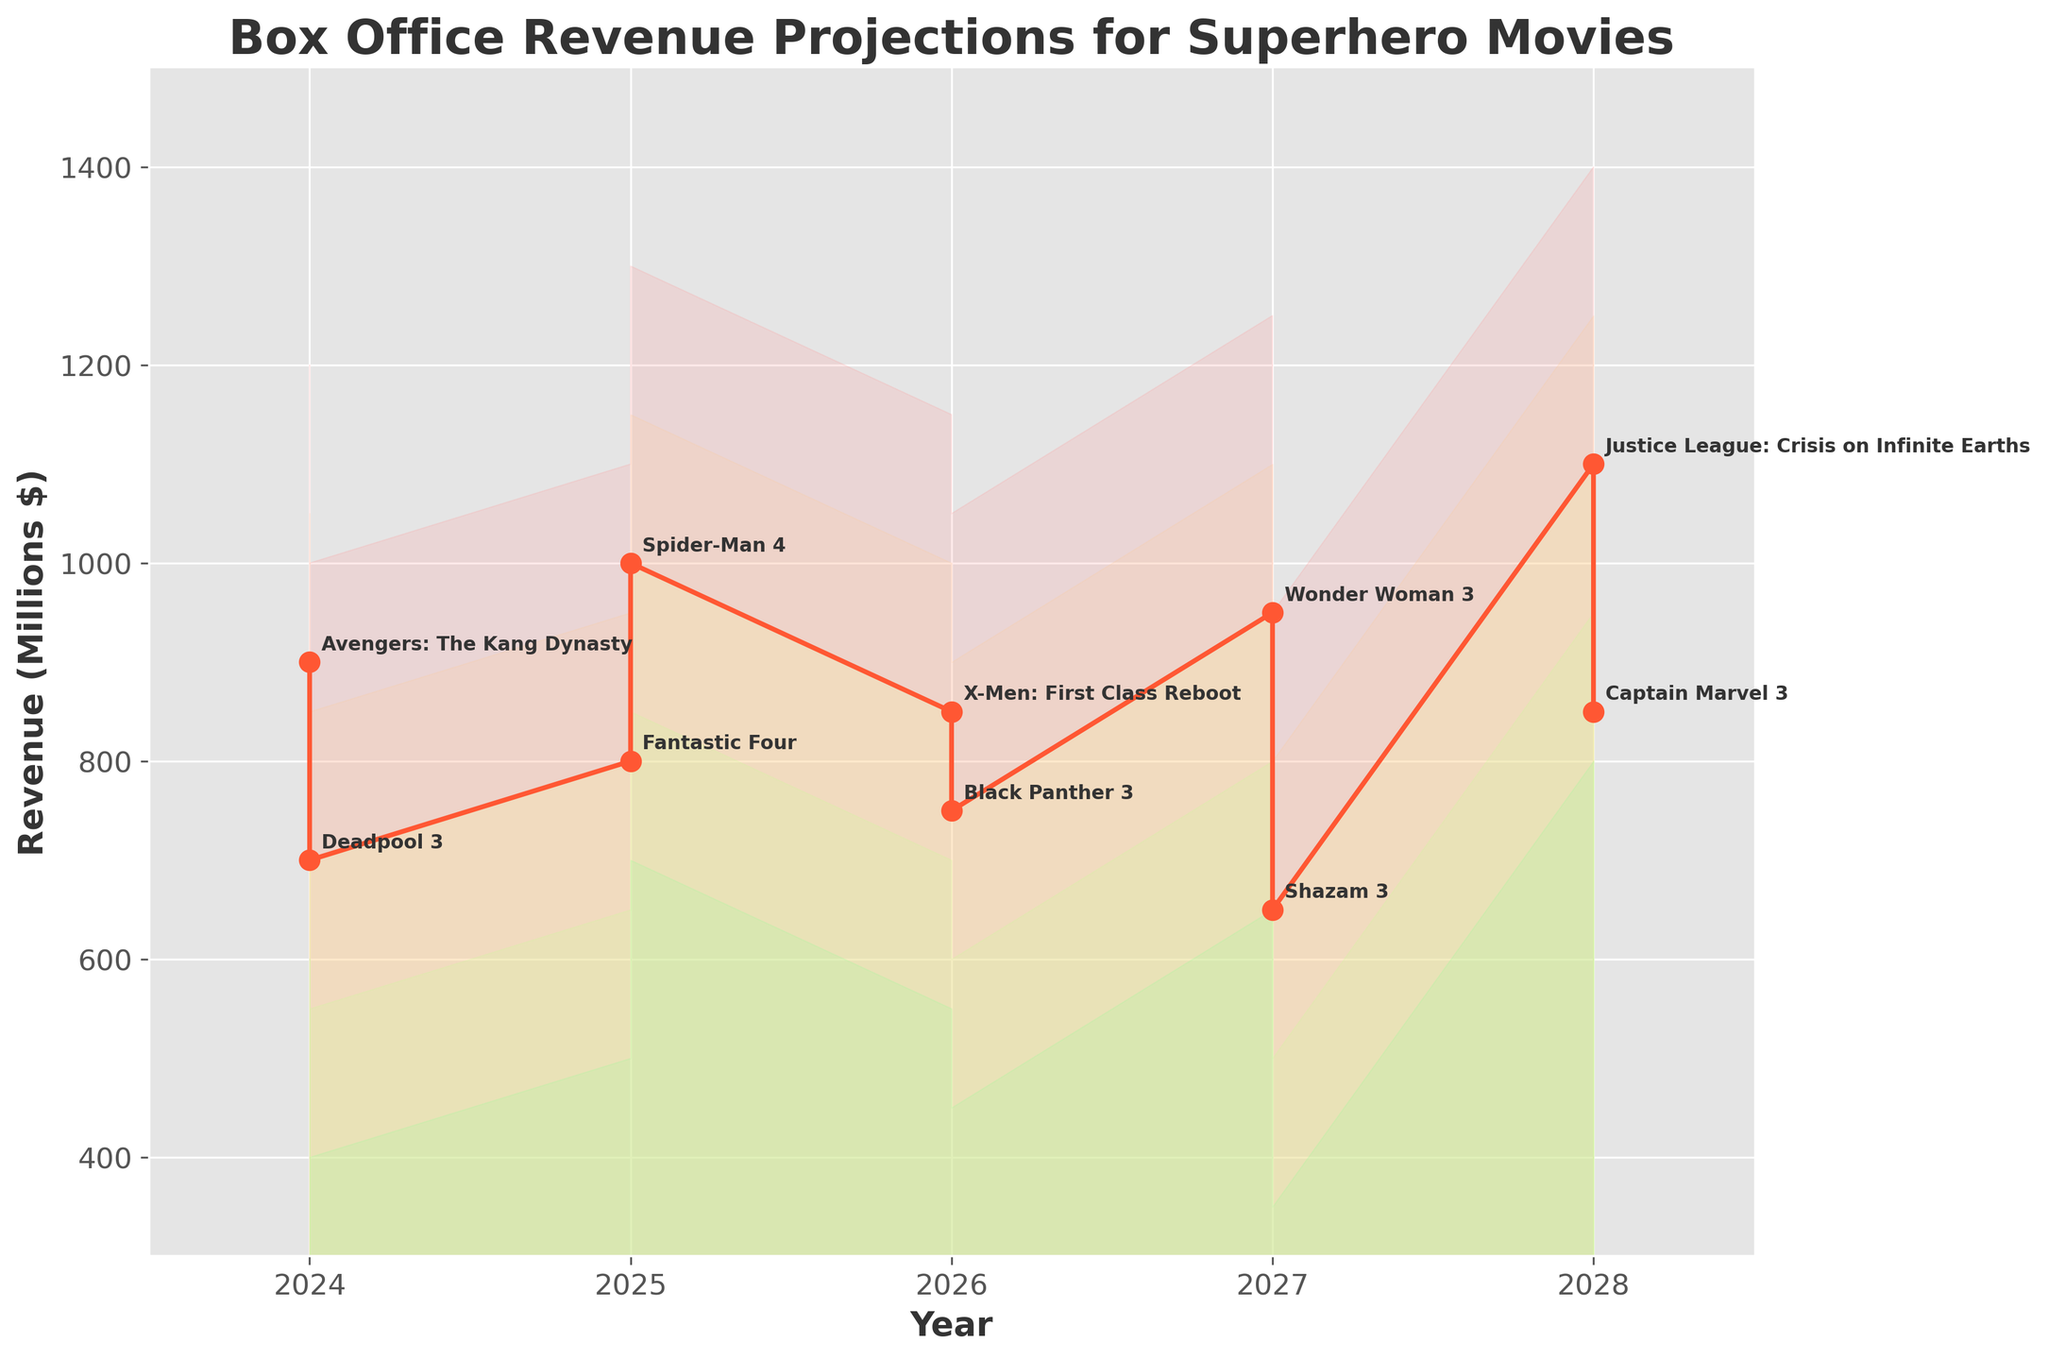How many movies are projected in the figure? By looking at the annotation labels on the figure, we can count the number of unique movies listed.
Answer: 10 What is the title of the figure? The title is usually located at the top of the figure and summarizes the main focus of the chart.
Answer: Box Office Revenue Projections for Superhero Movies Which movie is projected to have the highest revenue in 2028? By inspecting the projected revenue ranges for 2028, we can identify which movie has the highest upper bound.
Answer: Justice League: Crisis on Infinite Earths Which year has the most significant number of movies projected? By counting the number of unique movies for each year, we can determine which year has the most.
Answer: 2027 What is the minimum projected revenue for "Avengers: The Kang Dynasty" in 2024? The minimum revenue projection for each movie is given by the "Low" value in the data.
Answer: 600 million dollars Which movie shows a higher mid-range revenue projection in 2026, "X-Men: First Class Reboot" or "Black Panther 3"? Compare the "Mid" values for both movies in 2026.
Answer: X-Men: First Class Reboot Between "Spider-Man 4" and "Fantastic Four" in 2025, which movie has the lowest projected revenue at the high estimation? Compare the "High" values for both movies in 2025.
Answer: Fantastic Four What is the difference between the highest and lowest revenue projections for "Shazam 3" in 2027? Subtract the "Low" value from the "High" value for "Shazam 3" in 2027.
Answer: 600 million dollars Which movie's revenue projection falls within the smallest range in 2024? Identify which movie has the smallest difference between the "Low" and "High" values in 2024.
Answer: Deadpool 3 Based on the mid-range projections, what is the average projected revenue for movies in 2026? Sum up the "Mid" values for "X-Men: First Class Reboot" and "Black Panther 3" in 2026, then divide by 2.
Answer: 800 million dollars 